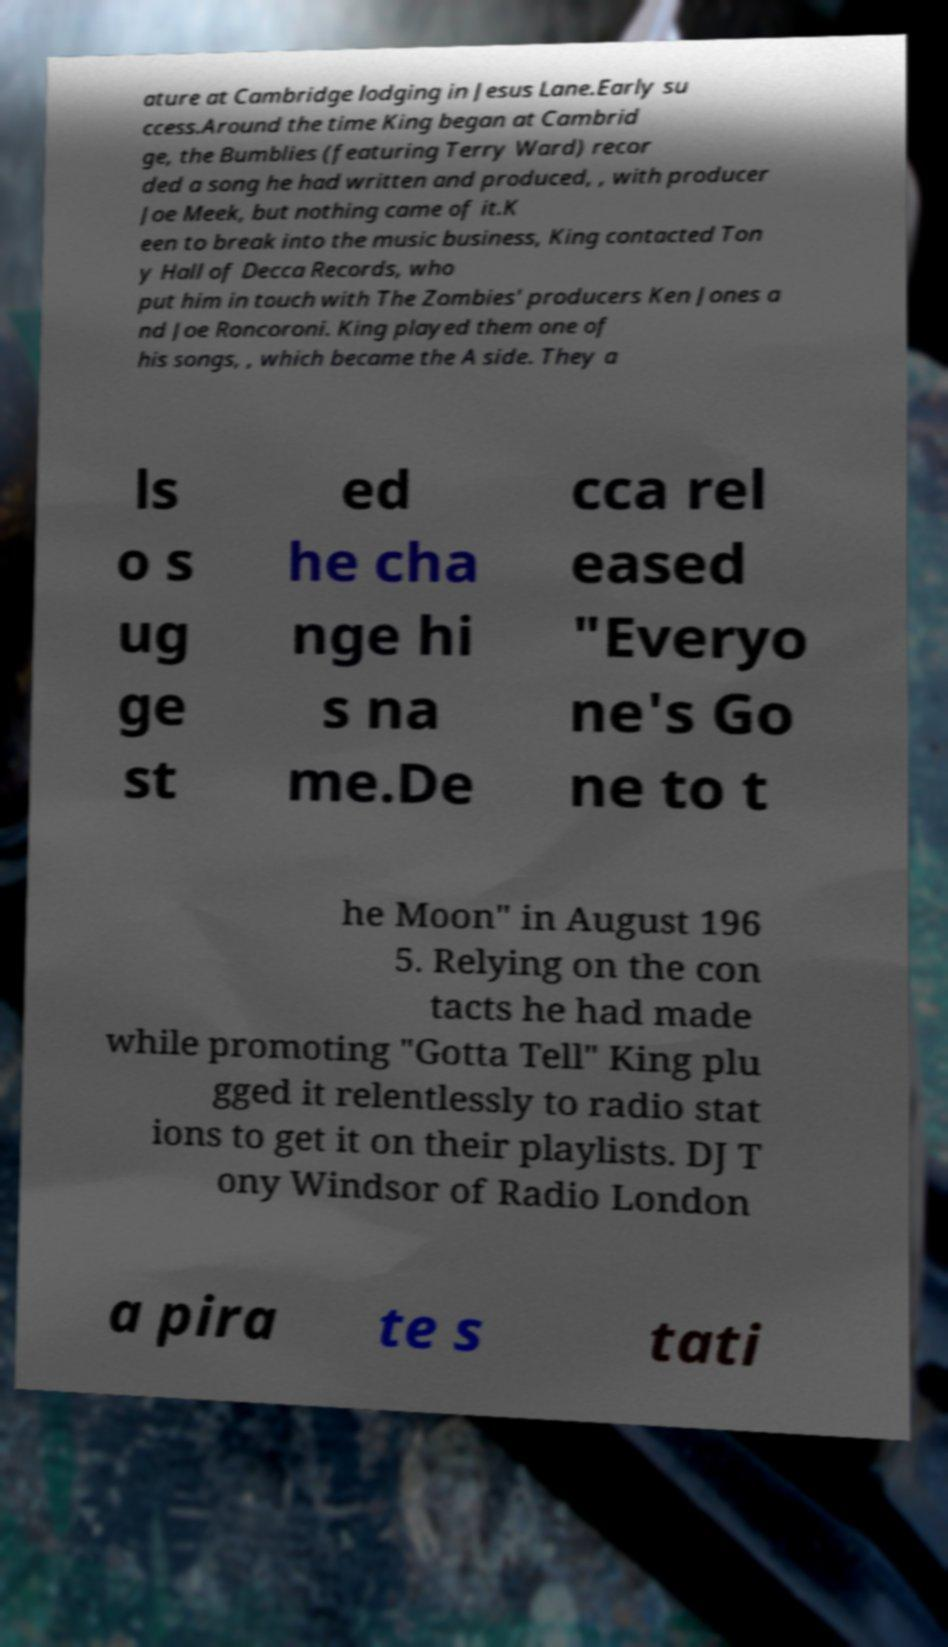I need the written content from this picture converted into text. Can you do that? ature at Cambridge lodging in Jesus Lane.Early su ccess.Around the time King began at Cambrid ge, the Bumblies (featuring Terry Ward) recor ded a song he had written and produced, , with producer Joe Meek, but nothing came of it.K een to break into the music business, King contacted Ton y Hall of Decca Records, who put him in touch with The Zombies' producers Ken Jones a nd Joe Roncoroni. King played them one of his songs, , which became the A side. They a ls o s ug ge st ed he cha nge hi s na me.De cca rel eased "Everyo ne's Go ne to t he Moon" in August 196 5. Relying on the con tacts he had made while promoting "Gotta Tell" King plu gged it relentlessly to radio stat ions to get it on their playlists. DJ T ony Windsor of Radio London a pira te s tati 